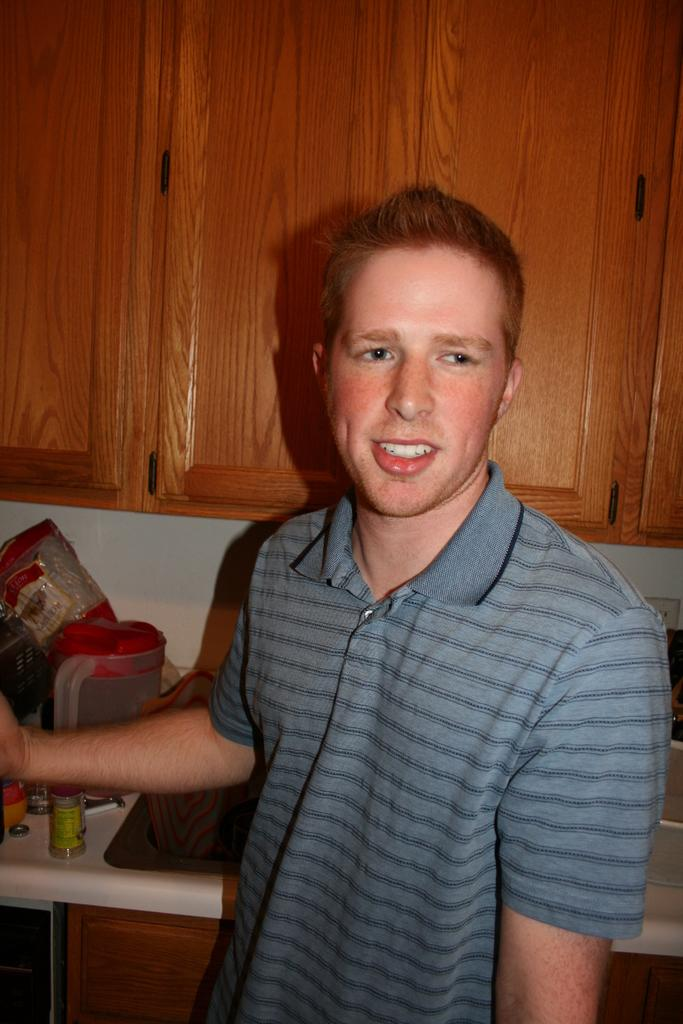What is the main subject of the image? There is a man in the image. What is the man doing in the image? The man is standing and smiling. What can be seen in the background of the image? There is a wooden shelf in the background of the image. What type of battle is taking place in the image? There is no battle present in the image; it features a man standing and smiling. How many children are visible in the image? There are no children present in the image. 